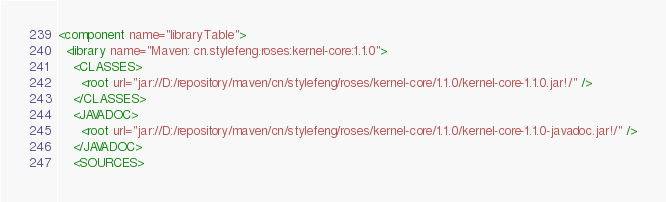<code> <loc_0><loc_0><loc_500><loc_500><_XML_><component name="libraryTable">
  <library name="Maven: cn.stylefeng.roses:kernel-core:1.1.0">
    <CLASSES>
      <root url="jar://D:/repository/maven/cn/stylefeng/roses/kernel-core/1.1.0/kernel-core-1.1.0.jar!/" />
    </CLASSES>
    <JAVADOC>
      <root url="jar://D:/repository/maven/cn/stylefeng/roses/kernel-core/1.1.0/kernel-core-1.1.0-javadoc.jar!/" />
    </JAVADOC>
    <SOURCES></code> 